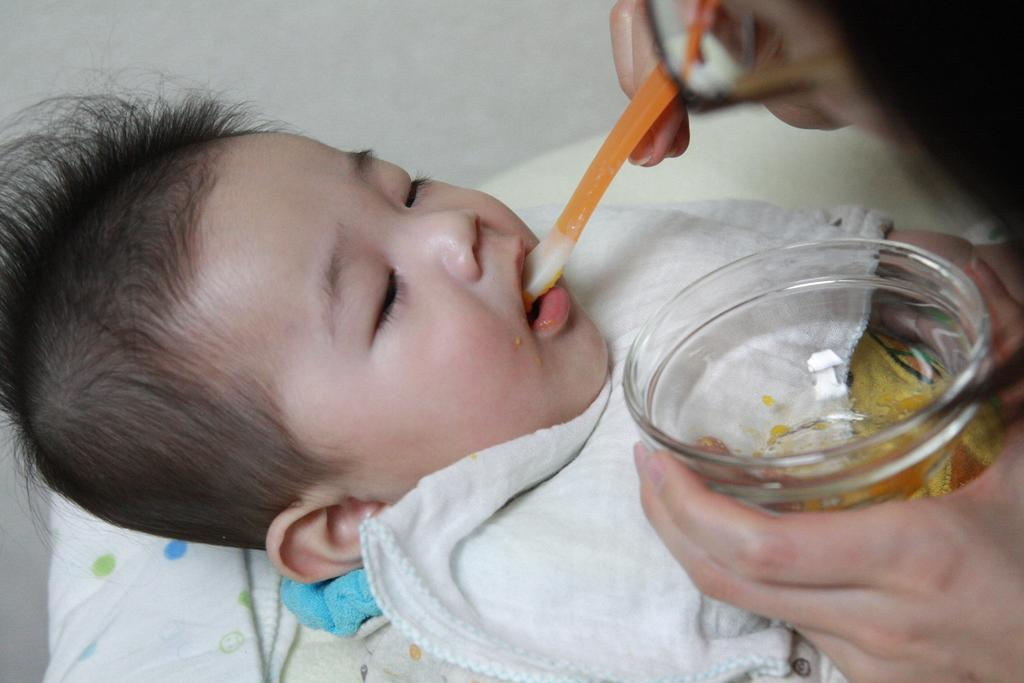What is the main subject of the image? The main subject of the image is a baby sleeping on the bed. What is the person in the image doing? The person is feeding the baby with a spoon. What is the person holding while feeding the baby? The person is holding a glass bowl. What type of peace symbol can be seen in the image? There is no peace symbol present in the image. Is there an airplane visible in the image? No, there is no airplane visible in the image. What kind of toy is the baby playing with in the image? There is no toy present in the image; the baby is sleeping. 